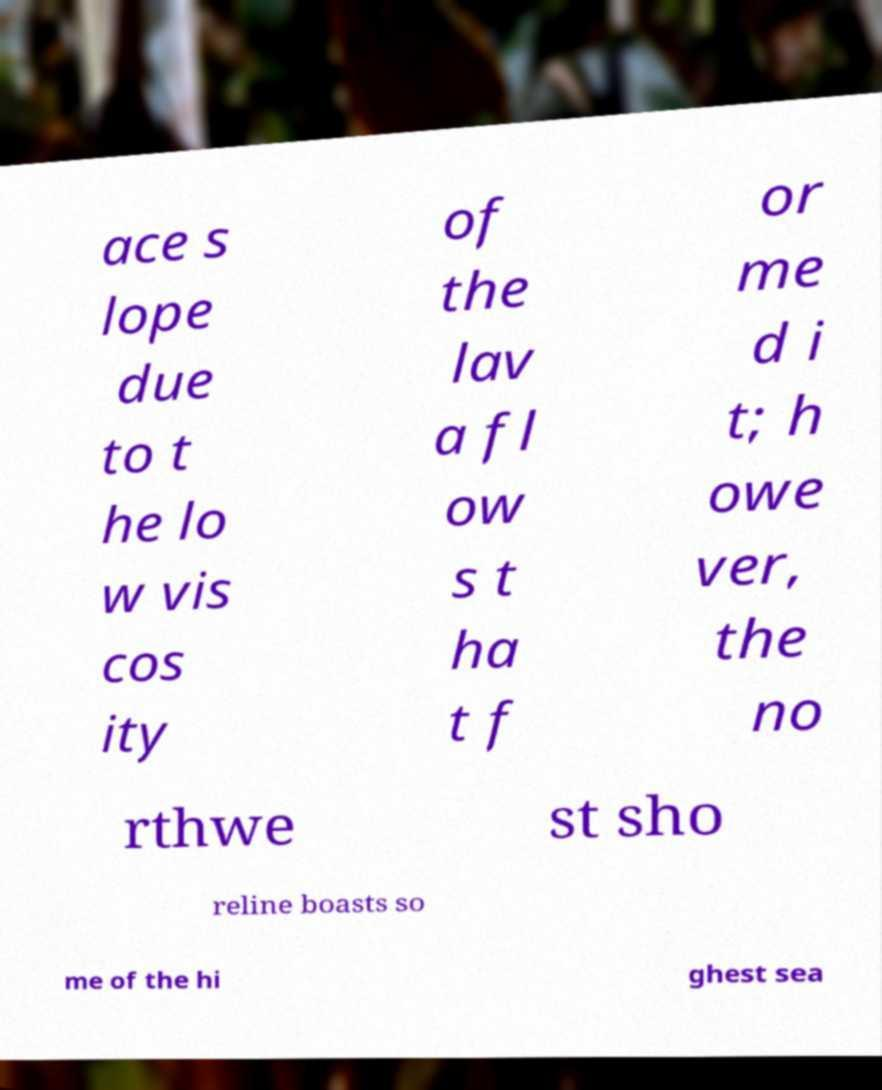For documentation purposes, I need the text within this image transcribed. Could you provide that? ace s lope due to t he lo w vis cos ity of the lav a fl ow s t ha t f or me d i t; h owe ver, the no rthwe st sho reline boasts so me of the hi ghest sea 